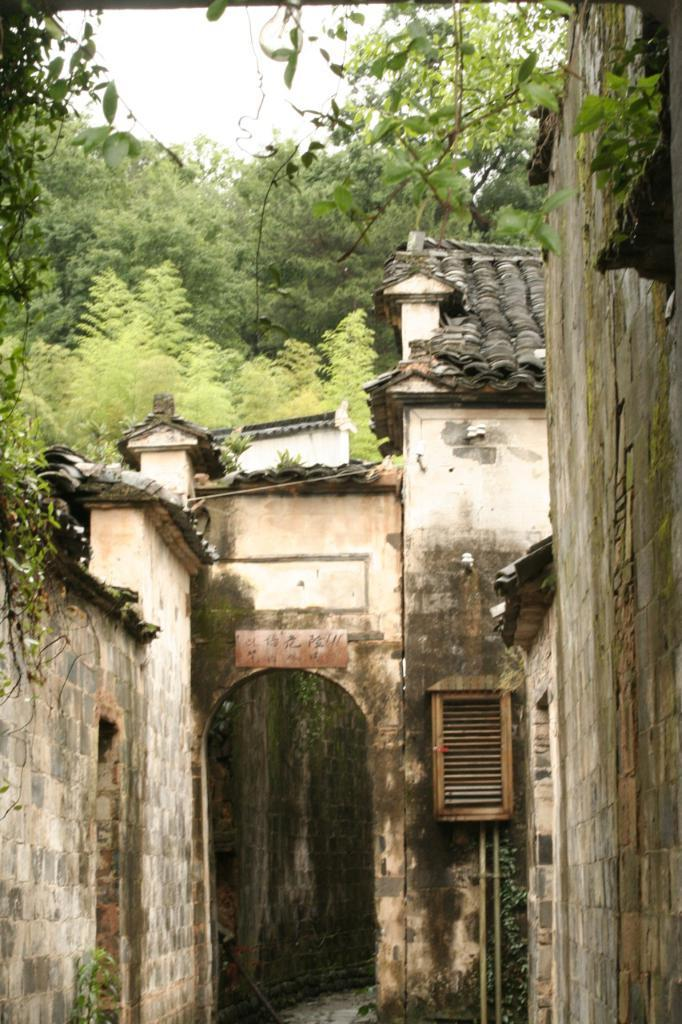What type of structures are located in the front of the image? There are buildings in the front of the image. What type of natural elements can be seen in the background of the image? There are trees in the background of the image. How does the sense of smell play a role in the image? There is no indication of smell or any sensory experience in the image, as it only shows buildings and trees. What type of adjustment can be seen being made to the bike in the image? There is no bike present in the image, so no adjustments can be observed. 